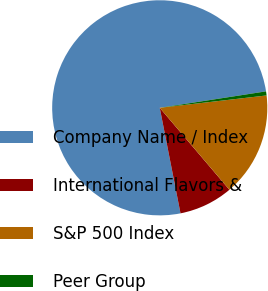Convert chart to OTSL. <chart><loc_0><loc_0><loc_500><loc_500><pie_chart><fcel>Company Name / Index<fcel>International Flavors &<fcel>S&P 500 Index<fcel>Peer Group<nl><fcel>75.65%<fcel>8.12%<fcel>15.62%<fcel>0.61%<nl></chart> 